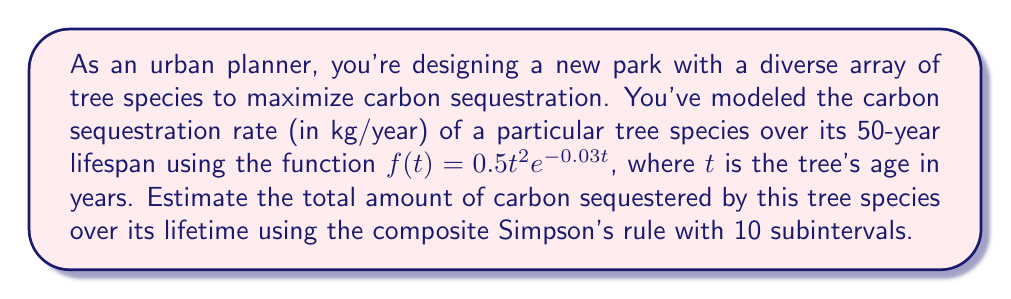Can you answer this question? To estimate the total carbon sequestered, we need to integrate the given function over the tree's lifespan:

$$\int_0^{50} f(t) dt = \int_0^{50} 0.5t^2e^{-0.03t} dt$$

We'll use the composite Simpson's rule with 10 subintervals:

$$\int_a^b f(x) dx \approx \frac{h}{3}\left[f(x_0) + 4f(x_1) + 2f(x_2) + 4f(x_3) + ... + 2f(x_{n-2}) + 4f(x_{n-1}) + f(x_n)\right]$$

Where $h = \frac{b-a}{n}$, $n$ is the number of subintervals, and $x_i = a + ih$ for $i = 0, 1, ..., n$.

1) Calculate $h$:
   $h = \frac{50-0}{10} = 5$

2) Calculate $x_i$ values:
   $x_0 = 0, x_1 = 5, x_2 = 10, ..., x_{10} = 50$

3) Evaluate $f(x_i)$ for each point:
   $f(0) = 0$
   $f(5) = 0.5(5^2)e^{-0.03(5)} = 10.88$
   $f(10) = 0.5(10^2)e^{-0.03(10)} = 36.79$
   $f(15) = 0.5(15^2)e^{-0.03(15)} = 71.22$
   $f(20) = 0.5(20^2)e^{-0.03(20)} = 109.91$
   $f(25) = 0.5(25^2)e^{-0.03(25)} = 149.36$
   $f(30) = 0.5(30^2)e^{-0.03(30)} = 187.39$
   $f(35) = 0.5(35^2)e^{-0.03(35)} = 221.93$
   $f(40) = 0.5(40^2)e^{-0.03(40)} = 251.79$
   $f(45) = 0.5(45^2)e^{-0.03(45)} = 276.16$
   $f(50) = 0.5(50^2)e^{-0.03(50)} = 294.77$

4) Apply the composite Simpson's rule:

$$\begin{aligned}
\int_0^{50} f(t) dt &\approx \frac{5}{3}[0 + 4(10.88) + 2(36.79) + 4(71.22) + 2(109.91) \\
&+ 4(149.36) + 2(187.39) + 4(221.93) + 2(251.79) \\
&+ 4(276.16) + 294.77] \\
&= \frac{5}{3}[7114.49] \\
&= 11857.48
\end{aligned}$$

Therefore, the estimated total carbon sequestered over the tree's 50-year lifespan is approximately 11,857.48 kg.
Answer: 11,857.48 kg 